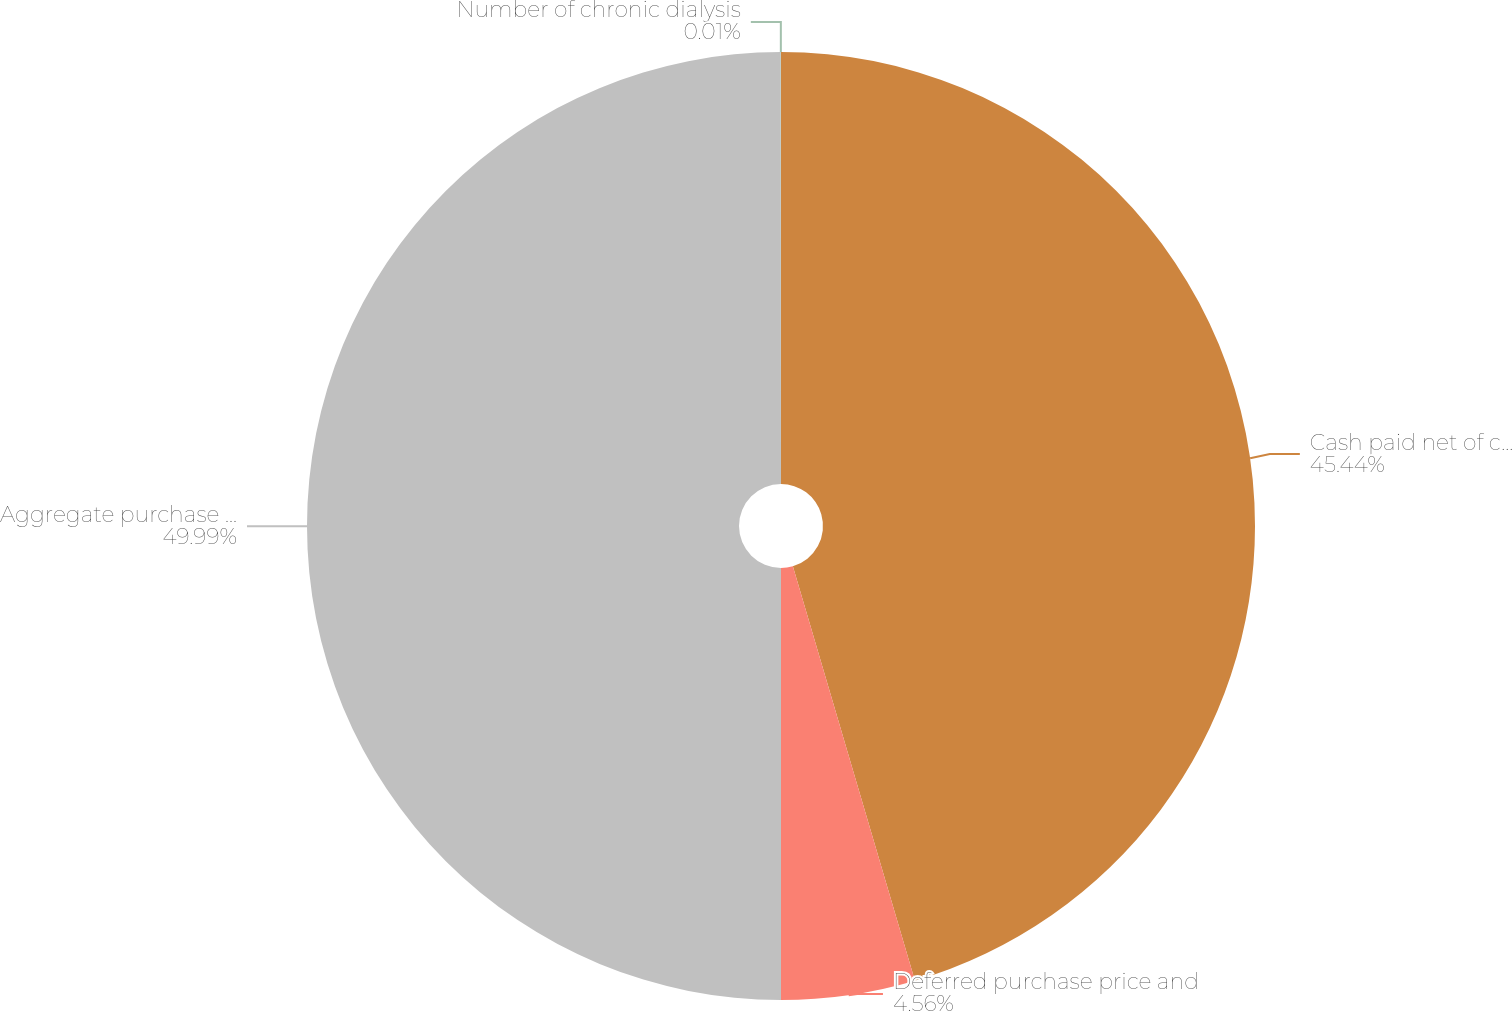Convert chart to OTSL. <chart><loc_0><loc_0><loc_500><loc_500><pie_chart><fcel>Cash paid net of cash acquired<fcel>Deferred purchase price and<fcel>Aggregate purchase cost<fcel>Number of chronic dialysis<nl><fcel>45.44%<fcel>4.56%<fcel>49.99%<fcel>0.01%<nl></chart> 